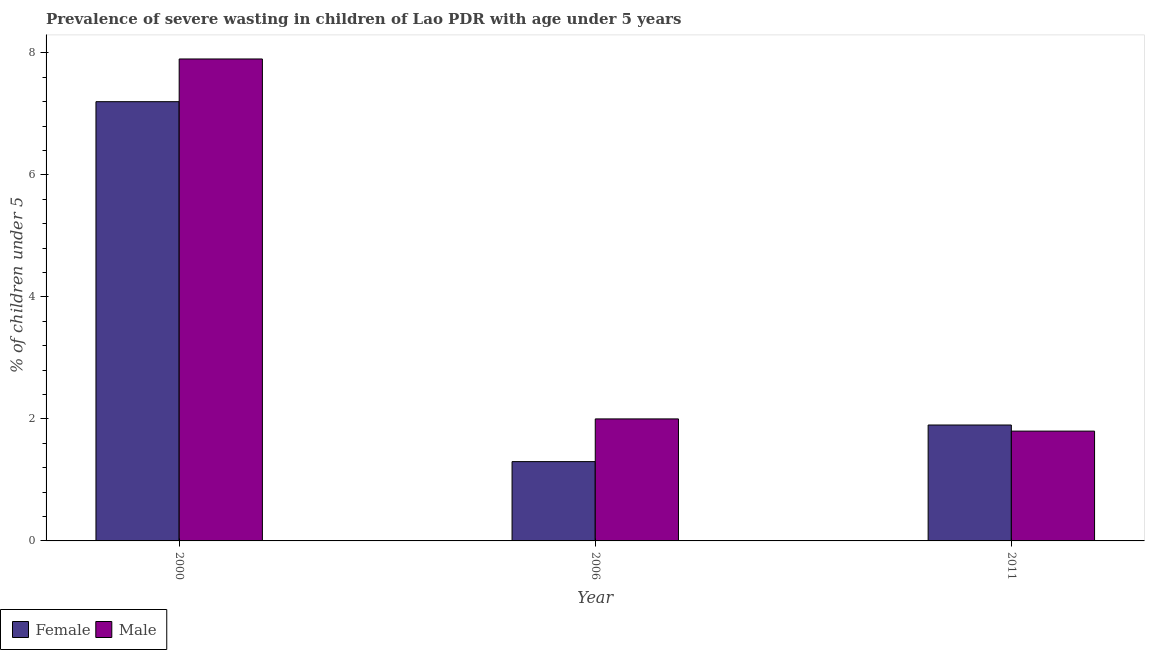How many different coloured bars are there?
Keep it short and to the point. 2. How many groups of bars are there?
Give a very brief answer. 3. How many bars are there on the 2nd tick from the left?
Provide a short and direct response. 2. How many bars are there on the 2nd tick from the right?
Your answer should be very brief. 2. What is the label of the 3rd group of bars from the left?
Provide a short and direct response. 2011. What is the percentage of undernourished male children in 2000?
Make the answer very short. 7.9. Across all years, what is the maximum percentage of undernourished male children?
Your answer should be compact. 7.9. Across all years, what is the minimum percentage of undernourished male children?
Your answer should be very brief. 1.8. In which year was the percentage of undernourished male children minimum?
Provide a short and direct response. 2011. What is the total percentage of undernourished male children in the graph?
Your answer should be compact. 11.7. What is the difference between the percentage of undernourished female children in 2000 and that in 2006?
Ensure brevity in your answer.  5.9. What is the difference between the percentage of undernourished female children in 2011 and the percentage of undernourished male children in 2006?
Provide a short and direct response. 0.6. What is the average percentage of undernourished male children per year?
Your answer should be very brief. 3.9. In the year 2006, what is the difference between the percentage of undernourished male children and percentage of undernourished female children?
Your answer should be very brief. 0. What is the ratio of the percentage of undernourished female children in 2000 to that in 2006?
Your answer should be compact. 5.54. What is the difference between the highest and the second highest percentage of undernourished male children?
Keep it short and to the point. 5.9. What is the difference between the highest and the lowest percentage of undernourished female children?
Offer a very short reply. 5.9. What does the 2nd bar from the left in 2006 represents?
Your answer should be compact. Male. How many bars are there?
Your answer should be very brief. 6. What is the difference between two consecutive major ticks on the Y-axis?
Your answer should be very brief. 2. Does the graph contain grids?
Offer a terse response. No. How many legend labels are there?
Make the answer very short. 2. How are the legend labels stacked?
Keep it short and to the point. Horizontal. What is the title of the graph?
Make the answer very short. Prevalence of severe wasting in children of Lao PDR with age under 5 years. Does "UN agencies" appear as one of the legend labels in the graph?
Offer a terse response. No. What is the label or title of the Y-axis?
Your answer should be very brief.  % of children under 5. What is the  % of children under 5 in Female in 2000?
Provide a short and direct response. 7.2. What is the  % of children under 5 in Male in 2000?
Keep it short and to the point. 7.9. What is the  % of children under 5 of Female in 2006?
Give a very brief answer. 1.3. What is the  % of children under 5 of Female in 2011?
Give a very brief answer. 1.9. What is the  % of children under 5 of Male in 2011?
Ensure brevity in your answer.  1.8. Across all years, what is the maximum  % of children under 5 of Female?
Your answer should be compact. 7.2. Across all years, what is the maximum  % of children under 5 in Male?
Provide a short and direct response. 7.9. Across all years, what is the minimum  % of children under 5 of Female?
Your answer should be very brief. 1.3. Across all years, what is the minimum  % of children under 5 of Male?
Offer a very short reply. 1.8. What is the total  % of children under 5 in Female in the graph?
Your answer should be compact. 10.4. What is the difference between the  % of children under 5 of Female in 2000 and that in 2006?
Keep it short and to the point. 5.9. What is the difference between the  % of children under 5 of Female in 2006 and that in 2011?
Make the answer very short. -0.6. What is the difference between the  % of children under 5 in Male in 2006 and that in 2011?
Your response must be concise. 0.2. What is the average  % of children under 5 in Female per year?
Give a very brief answer. 3.47. What is the average  % of children under 5 in Male per year?
Your answer should be compact. 3.9. In the year 2000, what is the difference between the  % of children under 5 of Female and  % of children under 5 of Male?
Provide a short and direct response. -0.7. In the year 2011, what is the difference between the  % of children under 5 in Female and  % of children under 5 in Male?
Your response must be concise. 0.1. What is the ratio of the  % of children under 5 of Female in 2000 to that in 2006?
Your answer should be compact. 5.54. What is the ratio of the  % of children under 5 of Male in 2000 to that in 2006?
Offer a very short reply. 3.95. What is the ratio of the  % of children under 5 of Female in 2000 to that in 2011?
Provide a succinct answer. 3.79. What is the ratio of the  % of children under 5 in Male in 2000 to that in 2011?
Offer a very short reply. 4.39. What is the ratio of the  % of children under 5 in Female in 2006 to that in 2011?
Make the answer very short. 0.68. What is the ratio of the  % of children under 5 in Male in 2006 to that in 2011?
Ensure brevity in your answer.  1.11. What is the difference between the highest and the second highest  % of children under 5 of Female?
Your response must be concise. 5.3. 